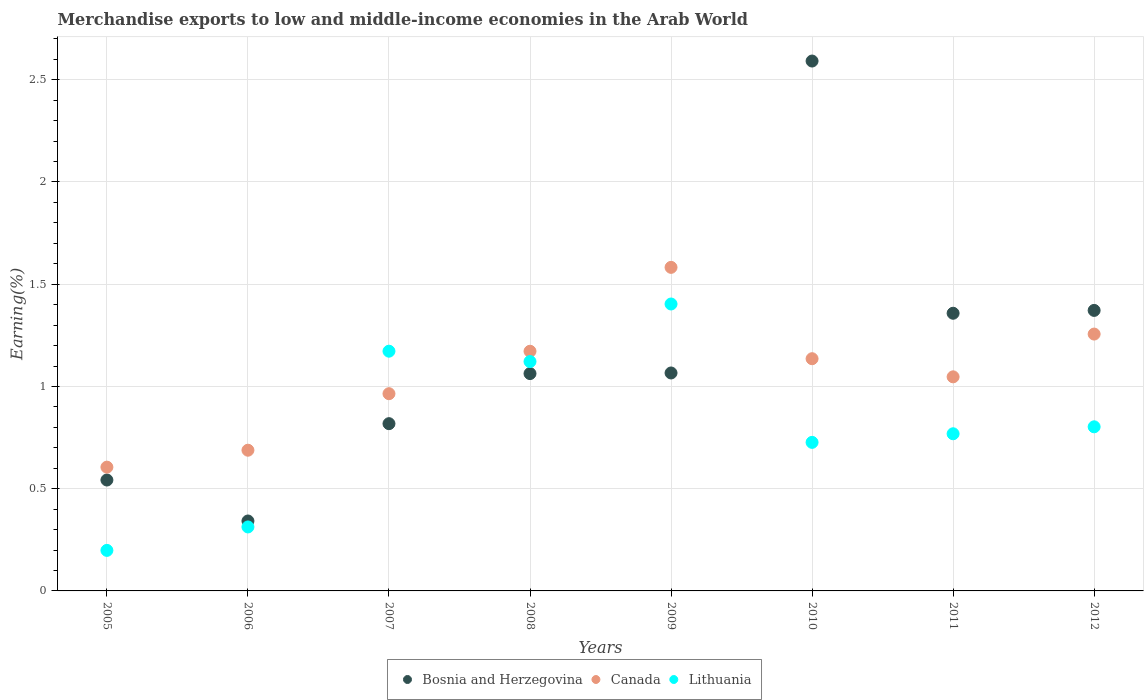How many different coloured dotlines are there?
Ensure brevity in your answer.  3. What is the percentage of amount earned from merchandise exports in Lithuania in 2008?
Provide a succinct answer. 1.12. Across all years, what is the maximum percentage of amount earned from merchandise exports in Canada?
Your answer should be compact. 1.58. Across all years, what is the minimum percentage of amount earned from merchandise exports in Bosnia and Herzegovina?
Give a very brief answer. 0.34. In which year was the percentage of amount earned from merchandise exports in Bosnia and Herzegovina minimum?
Ensure brevity in your answer.  2006. What is the total percentage of amount earned from merchandise exports in Lithuania in the graph?
Your answer should be compact. 6.51. What is the difference between the percentage of amount earned from merchandise exports in Lithuania in 2011 and that in 2012?
Offer a terse response. -0.03. What is the difference between the percentage of amount earned from merchandise exports in Lithuania in 2005 and the percentage of amount earned from merchandise exports in Canada in 2009?
Your answer should be very brief. -1.38. What is the average percentage of amount earned from merchandise exports in Bosnia and Herzegovina per year?
Your response must be concise. 1.14. In the year 2005, what is the difference between the percentage of amount earned from merchandise exports in Lithuania and percentage of amount earned from merchandise exports in Canada?
Offer a terse response. -0.41. In how many years, is the percentage of amount earned from merchandise exports in Canada greater than 1.9 %?
Give a very brief answer. 0. What is the ratio of the percentage of amount earned from merchandise exports in Canada in 2007 to that in 2012?
Offer a terse response. 0.77. Is the percentage of amount earned from merchandise exports in Lithuania in 2010 less than that in 2012?
Ensure brevity in your answer.  Yes. What is the difference between the highest and the second highest percentage of amount earned from merchandise exports in Bosnia and Herzegovina?
Ensure brevity in your answer.  1.22. What is the difference between the highest and the lowest percentage of amount earned from merchandise exports in Bosnia and Herzegovina?
Provide a short and direct response. 2.25. In how many years, is the percentage of amount earned from merchandise exports in Lithuania greater than the average percentage of amount earned from merchandise exports in Lithuania taken over all years?
Ensure brevity in your answer.  3. Is it the case that in every year, the sum of the percentage of amount earned from merchandise exports in Canada and percentage of amount earned from merchandise exports in Bosnia and Herzegovina  is greater than the percentage of amount earned from merchandise exports in Lithuania?
Your answer should be very brief. Yes. Is the percentage of amount earned from merchandise exports in Lithuania strictly greater than the percentage of amount earned from merchandise exports in Bosnia and Herzegovina over the years?
Keep it short and to the point. No. What is the difference between two consecutive major ticks on the Y-axis?
Ensure brevity in your answer.  0.5. Does the graph contain any zero values?
Keep it short and to the point. No. Does the graph contain grids?
Ensure brevity in your answer.  Yes. Where does the legend appear in the graph?
Your response must be concise. Bottom center. How are the legend labels stacked?
Your answer should be very brief. Horizontal. What is the title of the graph?
Keep it short and to the point. Merchandise exports to low and middle-income economies in the Arab World. What is the label or title of the X-axis?
Your response must be concise. Years. What is the label or title of the Y-axis?
Make the answer very short. Earning(%). What is the Earning(%) of Bosnia and Herzegovina in 2005?
Offer a very short reply. 0.54. What is the Earning(%) in Canada in 2005?
Ensure brevity in your answer.  0.61. What is the Earning(%) in Lithuania in 2005?
Make the answer very short. 0.2. What is the Earning(%) in Bosnia and Herzegovina in 2006?
Your answer should be very brief. 0.34. What is the Earning(%) of Canada in 2006?
Keep it short and to the point. 0.69. What is the Earning(%) of Lithuania in 2006?
Provide a short and direct response. 0.31. What is the Earning(%) of Bosnia and Herzegovina in 2007?
Offer a terse response. 0.82. What is the Earning(%) in Canada in 2007?
Provide a succinct answer. 0.96. What is the Earning(%) in Lithuania in 2007?
Provide a short and direct response. 1.17. What is the Earning(%) of Bosnia and Herzegovina in 2008?
Make the answer very short. 1.06. What is the Earning(%) of Canada in 2008?
Provide a succinct answer. 1.17. What is the Earning(%) in Lithuania in 2008?
Offer a terse response. 1.12. What is the Earning(%) of Bosnia and Herzegovina in 2009?
Offer a terse response. 1.07. What is the Earning(%) of Canada in 2009?
Offer a very short reply. 1.58. What is the Earning(%) of Lithuania in 2009?
Provide a succinct answer. 1.4. What is the Earning(%) in Bosnia and Herzegovina in 2010?
Your answer should be compact. 2.59. What is the Earning(%) in Canada in 2010?
Your response must be concise. 1.14. What is the Earning(%) of Lithuania in 2010?
Your answer should be compact. 0.73. What is the Earning(%) in Bosnia and Herzegovina in 2011?
Your answer should be compact. 1.36. What is the Earning(%) of Canada in 2011?
Provide a short and direct response. 1.05. What is the Earning(%) in Lithuania in 2011?
Your answer should be compact. 0.77. What is the Earning(%) of Bosnia and Herzegovina in 2012?
Your response must be concise. 1.37. What is the Earning(%) of Canada in 2012?
Ensure brevity in your answer.  1.26. What is the Earning(%) of Lithuania in 2012?
Give a very brief answer. 0.8. Across all years, what is the maximum Earning(%) of Bosnia and Herzegovina?
Make the answer very short. 2.59. Across all years, what is the maximum Earning(%) in Canada?
Ensure brevity in your answer.  1.58. Across all years, what is the maximum Earning(%) in Lithuania?
Ensure brevity in your answer.  1.4. Across all years, what is the minimum Earning(%) in Bosnia and Herzegovina?
Keep it short and to the point. 0.34. Across all years, what is the minimum Earning(%) in Canada?
Your response must be concise. 0.61. Across all years, what is the minimum Earning(%) of Lithuania?
Ensure brevity in your answer.  0.2. What is the total Earning(%) in Bosnia and Herzegovina in the graph?
Give a very brief answer. 9.15. What is the total Earning(%) of Canada in the graph?
Your answer should be very brief. 8.45. What is the total Earning(%) in Lithuania in the graph?
Keep it short and to the point. 6.51. What is the difference between the Earning(%) of Bosnia and Herzegovina in 2005 and that in 2006?
Give a very brief answer. 0.2. What is the difference between the Earning(%) of Canada in 2005 and that in 2006?
Give a very brief answer. -0.08. What is the difference between the Earning(%) of Lithuania in 2005 and that in 2006?
Ensure brevity in your answer.  -0.11. What is the difference between the Earning(%) in Bosnia and Herzegovina in 2005 and that in 2007?
Offer a very short reply. -0.28. What is the difference between the Earning(%) of Canada in 2005 and that in 2007?
Give a very brief answer. -0.36. What is the difference between the Earning(%) in Lithuania in 2005 and that in 2007?
Provide a short and direct response. -0.97. What is the difference between the Earning(%) of Bosnia and Herzegovina in 2005 and that in 2008?
Your response must be concise. -0.52. What is the difference between the Earning(%) in Canada in 2005 and that in 2008?
Offer a terse response. -0.57. What is the difference between the Earning(%) in Lithuania in 2005 and that in 2008?
Keep it short and to the point. -0.92. What is the difference between the Earning(%) of Bosnia and Herzegovina in 2005 and that in 2009?
Your response must be concise. -0.52. What is the difference between the Earning(%) of Canada in 2005 and that in 2009?
Keep it short and to the point. -0.98. What is the difference between the Earning(%) in Lithuania in 2005 and that in 2009?
Offer a very short reply. -1.21. What is the difference between the Earning(%) of Bosnia and Herzegovina in 2005 and that in 2010?
Ensure brevity in your answer.  -2.05. What is the difference between the Earning(%) of Canada in 2005 and that in 2010?
Your answer should be compact. -0.53. What is the difference between the Earning(%) of Lithuania in 2005 and that in 2010?
Offer a terse response. -0.53. What is the difference between the Earning(%) of Bosnia and Herzegovina in 2005 and that in 2011?
Ensure brevity in your answer.  -0.82. What is the difference between the Earning(%) in Canada in 2005 and that in 2011?
Keep it short and to the point. -0.44. What is the difference between the Earning(%) in Lithuania in 2005 and that in 2011?
Keep it short and to the point. -0.57. What is the difference between the Earning(%) of Bosnia and Herzegovina in 2005 and that in 2012?
Offer a very short reply. -0.83. What is the difference between the Earning(%) in Canada in 2005 and that in 2012?
Your answer should be compact. -0.65. What is the difference between the Earning(%) of Lithuania in 2005 and that in 2012?
Ensure brevity in your answer.  -0.6. What is the difference between the Earning(%) in Bosnia and Herzegovina in 2006 and that in 2007?
Your response must be concise. -0.48. What is the difference between the Earning(%) of Canada in 2006 and that in 2007?
Provide a short and direct response. -0.28. What is the difference between the Earning(%) of Lithuania in 2006 and that in 2007?
Your response must be concise. -0.86. What is the difference between the Earning(%) of Bosnia and Herzegovina in 2006 and that in 2008?
Provide a succinct answer. -0.72. What is the difference between the Earning(%) in Canada in 2006 and that in 2008?
Your response must be concise. -0.48. What is the difference between the Earning(%) in Lithuania in 2006 and that in 2008?
Offer a terse response. -0.81. What is the difference between the Earning(%) of Bosnia and Herzegovina in 2006 and that in 2009?
Your answer should be very brief. -0.72. What is the difference between the Earning(%) in Canada in 2006 and that in 2009?
Your answer should be very brief. -0.89. What is the difference between the Earning(%) of Lithuania in 2006 and that in 2009?
Provide a succinct answer. -1.09. What is the difference between the Earning(%) of Bosnia and Herzegovina in 2006 and that in 2010?
Ensure brevity in your answer.  -2.25. What is the difference between the Earning(%) in Canada in 2006 and that in 2010?
Your response must be concise. -0.45. What is the difference between the Earning(%) of Lithuania in 2006 and that in 2010?
Offer a very short reply. -0.41. What is the difference between the Earning(%) in Bosnia and Herzegovina in 2006 and that in 2011?
Ensure brevity in your answer.  -1.02. What is the difference between the Earning(%) of Canada in 2006 and that in 2011?
Your answer should be compact. -0.36. What is the difference between the Earning(%) of Lithuania in 2006 and that in 2011?
Your answer should be very brief. -0.46. What is the difference between the Earning(%) of Bosnia and Herzegovina in 2006 and that in 2012?
Keep it short and to the point. -1.03. What is the difference between the Earning(%) in Canada in 2006 and that in 2012?
Give a very brief answer. -0.57. What is the difference between the Earning(%) in Lithuania in 2006 and that in 2012?
Provide a short and direct response. -0.49. What is the difference between the Earning(%) of Bosnia and Herzegovina in 2007 and that in 2008?
Offer a very short reply. -0.24. What is the difference between the Earning(%) of Canada in 2007 and that in 2008?
Provide a short and direct response. -0.21. What is the difference between the Earning(%) of Lithuania in 2007 and that in 2008?
Provide a short and direct response. 0.05. What is the difference between the Earning(%) of Bosnia and Herzegovina in 2007 and that in 2009?
Ensure brevity in your answer.  -0.25. What is the difference between the Earning(%) in Canada in 2007 and that in 2009?
Offer a very short reply. -0.62. What is the difference between the Earning(%) of Lithuania in 2007 and that in 2009?
Your answer should be compact. -0.23. What is the difference between the Earning(%) in Bosnia and Herzegovina in 2007 and that in 2010?
Ensure brevity in your answer.  -1.77. What is the difference between the Earning(%) of Canada in 2007 and that in 2010?
Keep it short and to the point. -0.17. What is the difference between the Earning(%) of Lithuania in 2007 and that in 2010?
Your answer should be compact. 0.45. What is the difference between the Earning(%) in Bosnia and Herzegovina in 2007 and that in 2011?
Offer a very short reply. -0.54. What is the difference between the Earning(%) in Canada in 2007 and that in 2011?
Ensure brevity in your answer.  -0.08. What is the difference between the Earning(%) in Lithuania in 2007 and that in 2011?
Make the answer very short. 0.4. What is the difference between the Earning(%) of Bosnia and Herzegovina in 2007 and that in 2012?
Offer a terse response. -0.55. What is the difference between the Earning(%) of Canada in 2007 and that in 2012?
Keep it short and to the point. -0.29. What is the difference between the Earning(%) in Lithuania in 2007 and that in 2012?
Your response must be concise. 0.37. What is the difference between the Earning(%) in Bosnia and Herzegovina in 2008 and that in 2009?
Keep it short and to the point. -0. What is the difference between the Earning(%) of Canada in 2008 and that in 2009?
Make the answer very short. -0.41. What is the difference between the Earning(%) in Lithuania in 2008 and that in 2009?
Keep it short and to the point. -0.28. What is the difference between the Earning(%) in Bosnia and Herzegovina in 2008 and that in 2010?
Your response must be concise. -1.53. What is the difference between the Earning(%) of Canada in 2008 and that in 2010?
Keep it short and to the point. 0.04. What is the difference between the Earning(%) in Lithuania in 2008 and that in 2010?
Offer a very short reply. 0.4. What is the difference between the Earning(%) in Bosnia and Herzegovina in 2008 and that in 2011?
Make the answer very short. -0.29. What is the difference between the Earning(%) in Canada in 2008 and that in 2011?
Provide a succinct answer. 0.13. What is the difference between the Earning(%) in Lithuania in 2008 and that in 2011?
Give a very brief answer. 0.35. What is the difference between the Earning(%) of Bosnia and Herzegovina in 2008 and that in 2012?
Your answer should be compact. -0.31. What is the difference between the Earning(%) of Canada in 2008 and that in 2012?
Provide a short and direct response. -0.08. What is the difference between the Earning(%) in Lithuania in 2008 and that in 2012?
Give a very brief answer. 0.32. What is the difference between the Earning(%) of Bosnia and Herzegovina in 2009 and that in 2010?
Provide a short and direct response. -1.53. What is the difference between the Earning(%) of Canada in 2009 and that in 2010?
Give a very brief answer. 0.45. What is the difference between the Earning(%) of Lithuania in 2009 and that in 2010?
Your response must be concise. 0.68. What is the difference between the Earning(%) of Bosnia and Herzegovina in 2009 and that in 2011?
Your answer should be compact. -0.29. What is the difference between the Earning(%) in Canada in 2009 and that in 2011?
Give a very brief answer. 0.54. What is the difference between the Earning(%) of Lithuania in 2009 and that in 2011?
Your response must be concise. 0.63. What is the difference between the Earning(%) in Bosnia and Herzegovina in 2009 and that in 2012?
Make the answer very short. -0.31. What is the difference between the Earning(%) of Canada in 2009 and that in 2012?
Offer a very short reply. 0.33. What is the difference between the Earning(%) in Lithuania in 2009 and that in 2012?
Ensure brevity in your answer.  0.6. What is the difference between the Earning(%) of Bosnia and Herzegovina in 2010 and that in 2011?
Ensure brevity in your answer.  1.23. What is the difference between the Earning(%) of Canada in 2010 and that in 2011?
Keep it short and to the point. 0.09. What is the difference between the Earning(%) in Lithuania in 2010 and that in 2011?
Your answer should be very brief. -0.04. What is the difference between the Earning(%) of Bosnia and Herzegovina in 2010 and that in 2012?
Keep it short and to the point. 1.22. What is the difference between the Earning(%) of Canada in 2010 and that in 2012?
Your answer should be very brief. -0.12. What is the difference between the Earning(%) of Lithuania in 2010 and that in 2012?
Provide a short and direct response. -0.08. What is the difference between the Earning(%) of Bosnia and Herzegovina in 2011 and that in 2012?
Ensure brevity in your answer.  -0.01. What is the difference between the Earning(%) in Canada in 2011 and that in 2012?
Give a very brief answer. -0.21. What is the difference between the Earning(%) of Lithuania in 2011 and that in 2012?
Keep it short and to the point. -0.03. What is the difference between the Earning(%) of Bosnia and Herzegovina in 2005 and the Earning(%) of Canada in 2006?
Make the answer very short. -0.15. What is the difference between the Earning(%) in Bosnia and Herzegovina in 2005 and the Earning(%) in Lithuania in 2006?
Keep it short and to the point. 0.23. What is the difference between the Earning(%) of Canada in 2005 and the Earning(%) of Lithuania in 2006?
Your answer should be compact. 0.29. What is the difference between the Earning(%) in Bosnia and Herzegovina in 2005 and the Earning(%) in Canada in 2007?
Your response must be concise. -0.42. What is the difference between the Earning(%) of Bosnia and Herzegovina in 2005 and the Earning(%) of Lithuania in 2007?
Give a very brief answer. -0.63. What is the difference between the Earning(%) in Canada in 2005 and the Earning(%) in Lithuania in 2007?
Provide a short and direct response. -0.57. What is the difference between the Earning(%) of Bosnia and Herzegovina in 2005 and the Earning(%) of Canada in 2008?
Provide a succinct answer. -0.63. What is the difference between the Earning(%) of Bosnia and Herzegovina in 2005 and the Earning(%) of Lithuania in 2008?
Provide a succinct answer. -0.58. What is the difference between the Earning(%) in Canada in 2005 and the Earning(%) in Lithuania in 2008?
Your answer should be compact. -0.52. What is the difference between the Earning(%) of Bosnia and Herzegovina in 2005 and the Earning(%) of Canada in 2009?
Your answer should be very brief. -1.04. What is the difference between the Earning(%) of Bosnia and Herzegovina in 2005 and the Earning(%) of Lithuania in 2009?
Give a very brief answer. -0.86. What is the difference between the Earning(%) of Canada in 2005 and the Earning(%) of Lithuania in 2009?
Keep it short and to the point. -0.8. What is the difference between the Earning(%) in Bosnia and Herzegovina in 2005 and the Earning(%) in Canada in 2010?
Offer a very short reply. -0.59. What is the difference between the Earning(%) in Bosnia and Herzegovina in 2005 and the Earning(%) in Lithuania in 2010?
Offer a terse response. -0.18. What is the difference between the Earning(%) of Canada in 2005 and the Earning(%) of Lithuania in 2010?
Offer a very short reply. -0.12. What is the difference between the Earning(%) in Bosnia and Herzegovina in 2005 and the Earning(%) in Canada in 2011?
Keep it short and to the point. -0.5. What is the difference between the Earning(%) in Bosnia and Herzegovina in 2005 and the Earning(%) in Lithuania in 2011?
Provide a short and direct response. -0.23. What is the difference between the Earning(%) in Canada in 2005 and the Earning(%) in Lithuania in 2011?
Ensure brevity in your answer.  -0.16. What is the difference between the Earning(%) in Bosnia and Herzegovina in 2005 and the Earning(%) in Canada in 2012?
Ensure brevity in your answer.  -0.71. What is the difference between the Earning(%) of Bosnia and Herzegovina in 2005 and the Earning(%) of Lithuania in 2012?
Provide a succinct answer. -0.26. What is the difference between the Earning(%) in Canada in 2005 and the Earning(%) in Lithuania in 2012?
Your answer should be compact. -0.2. What is the difference between the Earning(%) in Bosnia and Herzegovina in 2006 and the Earning(%) in Canada in 2007?
Give a very brief answer. -0.62. What is the difference between the Earning(%) of Bosnia and Herzegovina in 2006 and the Earning(%) of Lithuania in 2007?
Ensure brevity in your answer.  -0.83. What is the difference between the Earning(%) in Canada in 2006 and the Earning(%) in Lithuania in 2007?
Your answer should be very brief. -0.48. What is the difference between the Earning(%) of Bosnia and Herzegovina in 2006 and the Earning(%) of Canada in 2008?
Your answer should be very brief. -0.83. What is the difference between the Earning(%) in Bosnia and Herzegovina in 2006 and the Earning(%) in Lithuania in 2008?
Offer a very short reply. -0.78. What is the difference between the Earning(%) in Canada in 2006 and the Earning(%) in Lithuania in 2008?
Ensure brevity in your answer.  -0.43. What is the difference between the Earning(%) of Bosnia and Herzegovina in 2006 and the Earning(%) of Canada in 2009?
Your answer should be compact. -1.24. What is the difference between the Earning(%) of Bosnia and Herzegovina in 2006 and the Earning(%) of Lithuania in 2009?
Your response must be concise. -1.06. What is the difference between the Earning(%) in Canada in 2006 and the Earning(%) in Lithuania in 2009?
Your answer should be compact. -0.72. What is the difference between the Earning(%) of Bosnia and Herzegovina in 2006 and the Earning(%) of Canada in 2010?
Offer a very short reply. -0.79. What is the difference between the Earning(%) in Bosnia and Herzegovina in 2006 and the Earning(%) in Lithuania in 2010?
Give a very brief answer. -0.38. What is the difference between the Earning(%) in Canada in 2006 and the Earning(%) in Lithuania in 2010?
Ensure brevity in your answer.  -0.04. What is the difference between the Earning(%) in Bosnia and Herzegovina in 2006 and the Earning(%) in Canada in 2011?
Make the answer very short. -0.7. What is the difference between the Earning(%) in Bosnia and Herzegovina in 2006 and the Earning(%) in Lithuania in 2011?
Your response must be concise. -0.43. What is the difference between the Earning(%) of Canada in 2006 and the Earning(%) of Lithuania in 2011?
Keep it short and to the point. -0.08. What is the difference between the Earning(%) of Bosnia and Herzegovina in 2006 and the Earning(%) of Canada in 2012?
Your response must be concise. -0.91. What is the difference between the Earning(%) in Bosnia and Herzegovina in 2006 and the Earning(%) in Lithuania in 2012?
Provide a succinct answer. -0.46. What is the difference between the Earning(%) in Canada in 2006 and the Earning(%) in Lithuania in 2012?
Make the answer very short. -0.11. What is the difference between the Earning(%) of Bosnia and Herzegovina in 2007 and the Earning(%) of Canada in 2008?
Provide a short and direct response. -0.35. What is the difference between the Earning(%) of Bosnia and Herzegovina in 2007 and the Earning(%) of Lithuania in 2008?
Your answer should be very brief. -0.3. What is the difference between the Earning(%) in Canada in 2007 and the Earning(%) in Lithuania in 2008?
Make the answer very short. -0.16. What is the difference between the Earning(%) in Bosnia and Herzegovina in 2007 and the Earning(%) in Canada in 2009?
Provide a succinct answer. -0.76. What is the difference between the Earning(%) in Bosnia and Herzegovina in 2007 and the Earning(%) in Lithuania in 2009?
Your answer should be compact. -0.59. What is the difference between the Earning(%) in Canada in 2007 and the Earning(%) in Lithuania in 2009?
Your answer should be very brief. -0.44. What is the difference between the Earning(%) of Bosnia and Herzegovina in 2007 and the Earning(%) of Canada in 2010?
Your response must be concise. -0.32. What is the difference between the Earning(%) in Bosnia and Herzegovina in 2007 and the Earning(%) in Lithuania in 2010?
Your answer should be very brief. 0.09. What is the difference between the Earning(%) in Canada in 2007 and the Earning(%) in Lithuania in 2010?
Keep it short and to the point. 0.24. What is the difference between the Earning(%) in Bosnia and Herzegovina in 2007 and the Earning(%) in Canada in 2011?
Provide a short and direct response. -0.23. What is the difference between the Earning(%) of Bosnia and Herzegovina in 2007 and the Earning(%) of Lithuania in 2011?
Keep it short and to the point. 0.05. What is the difference between the Earning(%) in Canada in 2007 and the Earning(%) in Lithuania in 2011?
Your response must be concise. 0.2. What is the difference between the Earning(%) in Bosnia and Herzegovina in 2007 and the Earning(%) in Canada in 2012?
Ensure brevity in your answer.  -0.44. What is the difference between the Earning(%) in Bosnia and Herzegovina in 2007 and the Earning(%) in Lithuania in 2012?
Your response must be concise. 0.02. What is the difference between the Earning(%) of Canada in 2007 and the Earning(%) of Lithuania in 2012?
Ensure brevity in your answer.  0.16. What is the difference between the Earning(%) of Bosnia and Herzegovina in 2008 and the Earning(%) of Canada in 2009?
Offer a very short reply. -0.52. What is the difference between the Earning(%) of Bosnia and Herzegovina in 2008 and the Earning(%) of Lithuania in 2009?
Ensure brevity in your answer.  -0.34. What is the difference between the Earning(%) in Canada in 2008 and the Earning(%) in Lithuania in 2009?
Your response must be concise. -0.23. What is the difference between the Earning(%) of Bosnia and Herzegovina in 2008 and the Earning(%) of Canada in 2010?
Your answer should be compact. -0.07. What is the difference between the Earning(%) of Bosnia and Herzegovina in 2008 and the Earning(%) of Lithuania in 2010?
Offer a very short reply. 0.34. What is the difference between the Earning(%) of Canada in 2008 and the Earning(%) of Lithuania in 2010?
Offer a terse response. 0.45. What is the difference between the Earning(%) of Bosnia and Herzegovina in 2008 and the Earning(%) of Canada in 2011?
Give a very brief answer. 0.02. What is the difference between the Earning(%) of Bosnia and Herzegovina in 2008 and the Earning(%) of Lithuania in 2011?
Keep it short and to the point. 0.29. What is the difference between the Earning(%) of Canada in 2008 and the Earning(%) of Lithuania in 2011?
Your answer should be compact. 0.4. What is the difference between the Earning(%) in Bosnia and Herzegovina in 2008 and the Earning(%) in Canada in 2012?
Offer a terse response. -0.19. What is the difference between the Earning(%) in Bosnia and Herzegovina in 2008 and the Earning(%) in Lithuania in 2012?
Your answer should be compact. 0.26. What is the difference between the Earning(%) of Canada in 2008 and the Earning(%) of Lithuania in 2012?
Your answer should be compact. 0.37. What is the difference between the Earning(%) in Bosnia and Herzegovina in 2009 and the Earning(%) in Canada in 2010?
Provide a short and direct response. -0.07. What is the difference between the Earning(%) in Bosnia and Herzegovina in 2009 and the Earning(%) in Lithuania in 2010?
Make the answer very short. 0.34. What is the difference between the Earning(%) of Canada in 2009 and the Earning(%) of Lithuania in 2010?
Provide a succinct answer. 0.86. What is the difference between the Earning(%) in Bosnia and Herzegovina in 2009 and the Earning(%) in Canada in 2011?
Provide a succinct answer. 0.02. What is the difference between the Earning(%) of Bosnia and Herzegovina in 2009 and the Earning(%) of Lithuania in 2011?
Make the answer very short. 0.3. What is the difference between the Earning(%) of Canada in 2009 and the Earning(%) of Lithuania in 2011?
Make the answer very short. 0.81. What is the difference between the Earning(%) in Bosnia and Herzegovina in 2009 and the Earning(%) in Canada in 2012?
Keep it short and to the point. -0.19. What is the difference between the Earning(%) of Bosnia and Herzegovina in 2009 and the Earning(%) of Lithuania in 2012?
Give a very brief answer. 0.26. What is the difference between the Earning(%) of Canada in 2009 and the Earning(%) of Lithuania in 2012?
Give a very brief answer. 0.78. What is the difference between the Earning(%) of Bosnia and Herzegovina in 2010 and the Earning(%) of Canada in 2011?
Give a very brief answer. 1.54. What is the difference between the Earning(%) of Bosnia and Herzegovina in 2010 and the Earning(%) of Lithuania in 2011?
Offer a very short reply. 1.82. What is the difference between the Earning(%) in Canada in 2010 and the Earning(%) in Lithuania in 2011?
Your answer should be very brief. 0.37. What is the difference between the Earning(%) of Bosnia and Herzegovina in 2010 and the Earning(%) of Canada in 2012?
Your answer should be compact. 1.34. What is the difference between the Earning(%) of Bosnia and Herzegovina in 2010 and the Earning(%) of Lithuania in 2012?
Keep it short and to the point. 1.79. What is the difference between the Earning(%) of Canada in 2010 and the Earning(%) of Lithuania in 2012?
Your response must be concise. 0.33. What is the difference between the Earning(%) of Bosnia and Herzegovina in 2011 and the Earning(%) of Canada in 2012?
Offer a terse response. 0.1. What is the difference between the Earning(%) in Bosnia and Herzegovina in 2011 and the Earning(%) in Lithuania in 2012?
Your answer should be very brief. 0.56. What is the difference between the Earning(%) of Canada in 2011 and the Earning(%) of Lithuania in 2012?
Provide a succinct answer. 0.24. What is the average Earning(%) of Bosnia and Herzegovina per year?
Make the answer very short. 1.14. What is the average Earning(%) in Canada per year?
Provide a short and direct response. 1.06. What is the average Earning(%) in Lithuania per year?
Your answer should be compact. 0.81. In the year 2005, what is the difference between the Earning(%) in Bosnia and Herzegovina and Earning(%) in Canada?
Your response must be concise. -0.06. In the year 2005, what is the difference between the Earning(%) of Bosnia and Herzegovina and Earning(%) of Lithuania?
Ensure brevity in your answer.  0.34. In the year 2005, what is the difference between the Earning(%) of Canada and Earning(%) of Lithuania?
Your answer should be compact. 0.41. In the year 2006, what is the difference between the Earning(%) of Bosnia and Herzegovina and Earning(%) of Canada?
Provide a succinct answer. -0.35. In the year 2006, what is the difference between the Earning(%) in Bosnia and Herzegovina and Earning(%) in Lithuania?
Keep it short and to the point. 0.03. In the year 2006, what is the difference between the Earning(%) in Canada and Earning(%) in Lithuania?
Your response must be concise. 0.38. In the year 2007, what is the difference between the Earning(%) of Bosnia and Herzegovina and Earning(%) of Canada?
Make the answer very short. -0.15. In the year 2007, what is the difference between the Earning(%) of Bosnia and Herzegovina and Earning(%) of Lithuania?
Make the answer very short. -0.35. In the year 2007, what is the difference between the Earning(%) of Canada and Earning(%) of Lithuania?
Your answer should be compact. -0.21. In the year 2008, what is the difference between the Earning(%) of Bosnia and Herzegovina and Earning(%) of Canada?
Offer a very short reply. -0.11. In the year 2008, what is the difference between the Earning(%) of Bosnia and Herzegovina and Earning(%) of Lithuania?
Ensure brevity in your answer.  -0.06. In the year 2008, what is the difference between the Earning(%) in Canada and Earning(%) in Lithuania?
Offer a very short reply. 0.05. In the year 2009, what is the difference between the Earning(%) of Bosnia and Herzegovina and Earning(%) of Canada?
Provide a succinct answer. -0.52. In the year 2009, what is the difference between the Earning(%) in Bosnia and Herzegovina and Earning(%) in Lithuania?
Your answer should be compact. -0.34. In the year 2009, what is the difference between the Earning(%) in Canada and Earning(%) in Lithuania?
Provide a short and direct response. 0.18. In the year 2010, what is the difference between the Earning(%) of Bosnia and Herzegovina and Earning(%) of Canada?
Provide a succinct answer. 1.46. In the year 2010, what is the difference between the Earning(%) of Bosnia and Herzegovina and Earning(%) of Lithuania?
Offer a terse response. 1.86. In the year 2010, what is the difference between the Earning(%) of Canada and Earning(%) of Lithuania?
Your response must be concise. 0.41. In the year 2011, what is the difference between the Earning(%) of Bosnia and Herzegovina and Earning(%) of Canada?
Make the answer very short. 0.31. In the year 2011, what is the difference between the Earning(%) in Bosnia and Herzegovina and Earning(%) in Lithuania?
Your answer should be very brief. 0.59. In the year 2011, what is the difference between the Earning(%) in Canada and Earning(%) in Lithuania?
Offer a terse response. 0.28. In the year 2012, what is the difference between the Earning(%) in Bosnia and Herzegovina and Earning(%) in Canada?
Your response must be concise. 0.12. In the year 2012, what is the difference between the Earning(%) in Bosnia and Herzegovina and Earning(%) in Lithuania?
Provide a short and direct response. 0.57. In the year 2012, what is the difference between the Earning(%) in Canada and Earning(%) in Lithuania?
Your response must be concise. 0.45. What is the ratio of the Earning(%) in Bosnia and Herzegovina in 2005 to that in 2006?
Make the answer very short. 1.59. What is the ratio of the Earning(%) of Canada in 2005 to that in 2006?
Make the answer very short. 0.88. What is the ratio of the Earning(%) of Lithuania in 2005 to that in 2006?
Offer a very short reply. 0.63. What is the ratio of the Earning(%) in Bosnia and Herzegovina in 2005 to that in 2007?
Provide a short and direct response. 0.66. What is the ratio of the Earning(%) in Canada in 2005 to that in 2007?
Give a very brief answer. 0.63. What is the ratio of the Earning(%) in Lithuania in 2005 to that in 2007?
Make the answer very short. 0.17. What is the ratio of the Earning(%) in Bosnia and Herzegovina in 2005 to that in 2008?
Offer a very short reply. 0.51. What is the ratio of the Earning(%) in Canada in 2005 to that in 2008?
Ensure brevity in your answer.  0.52. What is the ratio of the Earning(%) of Lithuania in 2005 to that in 2008?
Offer a very short reply. 0.18. What is the ratio of the Earning(%) of Bosnia and Herzegovina in 2005 to that in 2009?
Your response must be concise. 0.51. What is the ratio of the Earning(%) in Canada in 2005 to that in 2009?
Provide a succinct answer. 0.38. What is the ratio of the Earning(%) in Lithuania in 2005 to that in 2009?
Your response must be concise. 0.14. What is the ratio of the Earning(%) in Bosnia and Herzegovina in 2005 to that in 2010?
Ensure brevity in your answer.  0.21. What is the ratio of the Earning(%) in Canada in 2005 to that in 2010?
Offer a terse response. 0.53. What is the ratio of the Earning(%) in Lithuania in 2005 to that in 2010?
Your response must be concise. 0.27. What is the ratio of the Earning(%) of Bosnia and Herzegovina in 2005 to that in 2011?
Your answer should be compact. 0.4. What is the ratio of the Earning(%) of Canada in 2005 to that in 2011?
Offer a very short reply. 0.58. What is the ratio of the Earning(%) in Lithuania in 2005 to that in 2011?
Provide a succinct answer. 0.26. What is the ratio of the Earning(%) in Bosnia and Herzegovina in 2005 to that in 2012?
Your response must be concise. 0.4. What is the ratio of the Earning(%) in Canada in 2005 to that in 2012?
Provide a short and direct response. 0.48. What is the ratio of the Earning(%) in Lithuania in 2005 to that in 2012?
Provide a succinct answer. 0.25. What is the ratio of the Earning(%) of Bosnia and Herzegovina in 2006 to that in 2007?
Make the answer very short. 0.42. What is the ratio of the Earning(%) in Canada in 2006 to that in 2007?
Your answer should be compact. 0.71. What is the ratio of the Earning(%) of Lithuania in 2006 to that in 2007?
Your response must be concise. 0.27. What is the ratio of the Earning(%) in Bosnia and Herzegovina in 2006 to that in 2008?
Your answer should be very brief. 0.32. What is the ratio of the Earning(%) of Canada in 2006 to that in 2008?
Offer a very short reply. 0.59. What is the ratio of the Earning(%) in Lithuania in 2006 to that in 2008?
Provide a succinct answer. 0.28. What is the ratio of the Earning(%) of Bosnia and Herzegovina in 2006 to that in 2009?
Provide a short and direct response. 0.32. What is the ratio of the Earning(%) of Canada in 2006 to that in 2009?
Your answer should be very brief. 0.43. What is the ratio of the Earning(%) in Lithuania in 2006 to that in 2009?
Provide a short and direct response. 0.22. What is the ratio of the Earning(%) of Bosnia and Herzegovina in 2006 to that in 2010?
Offer a terse response. 0.13. What is the ratio of the Earning(%) in Canada in 2006 to that in 2010?
Offer a very short reply. 0.61. What is the ratio of the Earning(%) in Lithuania in 2006 to that in 2010?
Ensure brevity in your answer.  0.43. What is the ratio of the Earning(%) in Bosnia and Herzegovina in 2006 to that in 2011?
Keep it short and to the point. 0.25. What is the ratio of the Earning(%) in Canada in 2006 to that in 2011?
Your response must be concise. 0.66. What is the ratio of the Earning(%) in Lithuania in 2006 to that in 2011?
Make the answer very short. 0.41. What is the ratio of the Earning(%) in Bosnia and Herzegovina in 2006 to that in 2012?
Offer a terse response. 0.25. What is the ratio of the Earning(%) of Canada in 2006 to that in 2012?
Offer a terse response. 0.55. What is the ratio of the Earning(%) of Lithuania in 2006 to that in 2012?
Keep it short and to the point. 0.39. What is the ratio of the Earning(%) in Bosnia and Herzegovina in 2007 to that in 2008?
Offer a terse response. 0.77. What is the ratio of the Earning(%) of Canada in 2007 to that in 2008?
Provide a succinct answer. 0.82. What is the ratio of the Earning(%) of Lithuania in 2007 to that in 2008?
Offer a very short reply. 1.05. What is the ratio of the Earning(%) of Bosnia and Herzegovina in 2007 to that in 2009?
Provide a succinct answer. 0.77. What is the ratio of the Earning(%) of Canada in 2007 to that in 2009?
Ensure brevity in your answer.  0.61. What is the ratio of the Earning(%) of Lithuania in 2007 to that in 2009?
Offer a terse response. 0.84. What is the ratio of the Earning(%) of Bosnia and Herzegovina in 2007 to that in 2010?
Provide a short and direct response. 0.32. What is the ratio of the Earning(%) in Canada in 2007 to that in 2010?
Offer a very short reply. 0.85. What is the ratio of the Earning(%) in Lithuania in 2007 to that in 2010?
Your response must be concise. 1.61. What is the ratio of the Earning(%) in Bosnia and Herzegovina in 2007 to that in 2011?
Provide a short and direct response. 0.6. What is the ratio of the Earning(%) in Canada in 2007 to that in 2011?
Your answer should be very brief. 0.92. What is the ratio of the Earning(%) in Lithuania in 2007 to that in 2011?
Your answer should be compact. 1.53. What is the ratio of the Earning(%) in Bosnia and Herzegovina in 2007 to that in 2012?
Ensure brevity in your answer.  0.6. What is the ratio of the Earning(%) of Canada in 2007 to that in 2012?
Offer a terse response. 0.77. What is the ratio of the Earning(%) in Lithuania in 2007 to that in 2012?
Provide a succinct answer. 1.46. What is the ratio of the Earning(%) in Canada in 2008 to that in 2009?
Make the answer very short. 0.74. What is the ratio of the Earning(%) in Lithuania in 2008 to that in 2009?
Offer a terse response. 0.8. What is the ratio of the Earning(%) of Bosnia and Herzegovina in 2008 to that in 2010?
Ensure brevity in your answer.  0.41. What is the ratio of the Earning(%) in Canada in 2008 to that in 2010?
Provide a succinct answer. 1.03. What is the ratio of the Earning(%) in Lithuania in 2008 to that in 2010?
Ensure brevity in your answer.  1.54. What is the ratio of the Earning(%) of Bosnia and Herzegovina in 2008 to that in 2011?
Make the answer very short. 0.78. What is the ratio of the Earning(%) of Canada in 2008 to that in 2011?
Your answer should be very brief. 1.12. What is the ratio of the Earning(%) in Lithuania in 2008 to that in 2011?
Offer a very short reply. 1.46. What is the ratio of the Earning(%) of Bosnia and Herzegovina in 2008 to that in 2012?
Provide a short and direct response. 0.77. What is the ratio of the Earning(%) in Canada in 2008 to that in 2012?
Keep it short and to the point. 0.93. What is the ratio of the Earning(%) of Lithuania in 2008 to that in 2012?
Provide a succinct answer. 1.4. What is the ratio of the Earning(%) of Bosnia and Herzegovina in 2009 to that in 2010?
Provide a succinct answer. 0.41. What is the ratio of the Earning(%) of Canada in 2009 to that in 2010?
Offer a very short reply. 1.39. What is the ratio of the Earning(%) in Lithuania in 2009 to that in 2010?
Offer a terse response. 1.93. What is the ratio of the Earning(%) of Bosnia and Herzegovina in 2009 to that in 2011?
Your response must be concise. 0.78. What is the ratio of the Earning(%) of Canada in 2009 to that in 2011?
Your answer should be compact. 1.51. What is the ratio of the Earning(%) in Lithuania in 2009 to that in 2011?
Your answer should be very brief. 1.83. What is the ratio of the Earning(%) of Bosnia and Herzegovina in 2009 to that in 2012?
Your answer should be compact. 0.78. What is the ratio of the Earning(%) in Canada in 2009 to that in 2012?
Make the answer very short. 1.26. What is the ratio of the Earning(%) in Lithuania in 2009 to that in 2012?
Your answer should be compact. 1.75. What is the ratio of the Earning(%) in Bosnia and Herzegovina in 2010 to that in 2011?
Make the answer very short. 1.91. What is the ratio of the Earning(%) in Canada in 2010 to that in 2011?
Provide a short and direct response. 1.08. What is the ratio of the Earning(%) of Lithuania in 2010 to that in 2011?
Keep it short and to the point. 0.95. What is the ratio of the Earning(%) of Bosnia and Herzegovina in 2010 to that in 2012?
Your answer should be compact. 1.89. What is the ratio of the Earning(%) in Canada in 2010 to that in 2012?
Make the answer very short. 0.9. What is the ratio of the Earning(%) in Lithuania in 2010 to that in 2012?
Offer a very short reply. 0.91. What is the ratio of the Earning(%) in Canada in 2011 to that in 2012?
Your answer should be compact. 0.83. What is the ratio of the Earning(%) in Lithuania in 2011 to that in 2012?
Make the answer very short. 0.96. What is the difference between the highest and the second highest Earning(%) of Bosnia and Herzegovina?
Ensure brevity in your answer.  1.22. What is the difference between the highest and the second highest Earning(%) of Canada?
Your answer should be compact. 0.33. What is the difference between the highest and the second highest Earning(%) of Lithuania?
Make the answer very short. 0.23. What is the difference between the highest and the lowest Earning(%) of Bosnia and Herzegovina?
Your response must be concise. 2.25. What is the difference between the highest and the lowest Earning(%) in Canada?
Give a very brief answer. 0.98. What is the difference between the highest and the lowest Earning(%) of Lithuania?
Give a very brief answer. 1.21. 